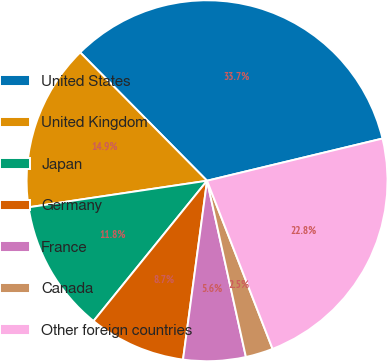<chart> <loc_0><loc_0><loc_500><loc_500><pie_chart><fcel>United States<fcel>United Kingdom<fcel>Japan<fcel>Germany<fcel>France<fcel>Canada<fcel>Other foreign countries<nl><fcel>33.65%<fcel>14.94%<fcel>11.82%<fcel>8.7%<fcel>5.58%<fcel>2.46%<fcel>22.84%<nl></chart> 